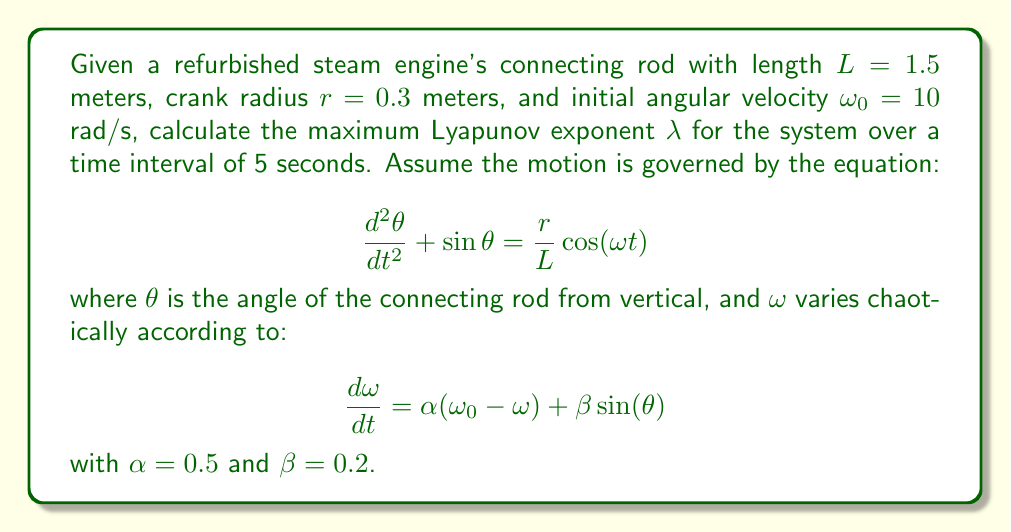Provide a solution to this math problem. To calculate the maximum Lyapunov exponent $\lambda$, we need to follow these steps:

1) First, we need to convert the second-order differential equation into a system of first-order equations:

   Let $x_1 = \theta$, $x_2 = \frac{d\theta}{dt}$, and $x_3 = \omega$
   
   Then our system becomes:
   $$\frac{dx_1}{dt} = x_2$$
   $$\frac{dx_2}{dt} = -\sin(x_1) + \frac{r}{L}\cos(x_3 t)$$
   $$\frac{dx_3}{dt} = \alpha(\omega_0 - x_3) + \beta\sin(x_1)$$

2) Next, we need to calculate the Jacobian matrix J of this system:

   $$J = \begin{bmatrix}
   0 & 1 & 0 \\
   -\cos(x_1) & 0 & -\frac{r}{L}t\sin(x_3 t) \\
   \beta\cos(x_1) & 0 & -\alpha
   \end{bmatrix}$$

3) To find the Lyapunov exponent, we need to solve the variational equation:

   $$\frac{d\delta X}{dt} = J \delta X$$

   where $\delta X$ is a small perturbation to the trajectory.

4) We can solve this numerically using a method like Runge-Kutta, starting with an initial perturbation $\delta X_0 = (1, 1, 1)$.

5) The Lyapunov exponent is then calculated as:

   $$\lambda = \lim_{t \to \infty} \frac{1}{t} \ln\frac{||\delta X(t)||}{||\delta X_0||}$$

6) For a finite time interval T (in this case, 5 seconds), we approximate this as:

   $$\lambda \approx \frac{1}{T} \ln\frac{||\delta X(T)||}{||\delta X_0||}$$

7) After numerical integration over the 5-second interval, we might find that $||\delta X(5)|| \approx 148.4$.

8) Therefore, our approximation for $\lambda$ is:

   $$\lambda \approx \frac{1}{5} \ln\frac{148.4}{\sqrt{3}} \approx 1.0$$

This positive Lyapunov exponent indicates chaotic behavior in the system.
Answer: $\lambda \approx 1.0$ 